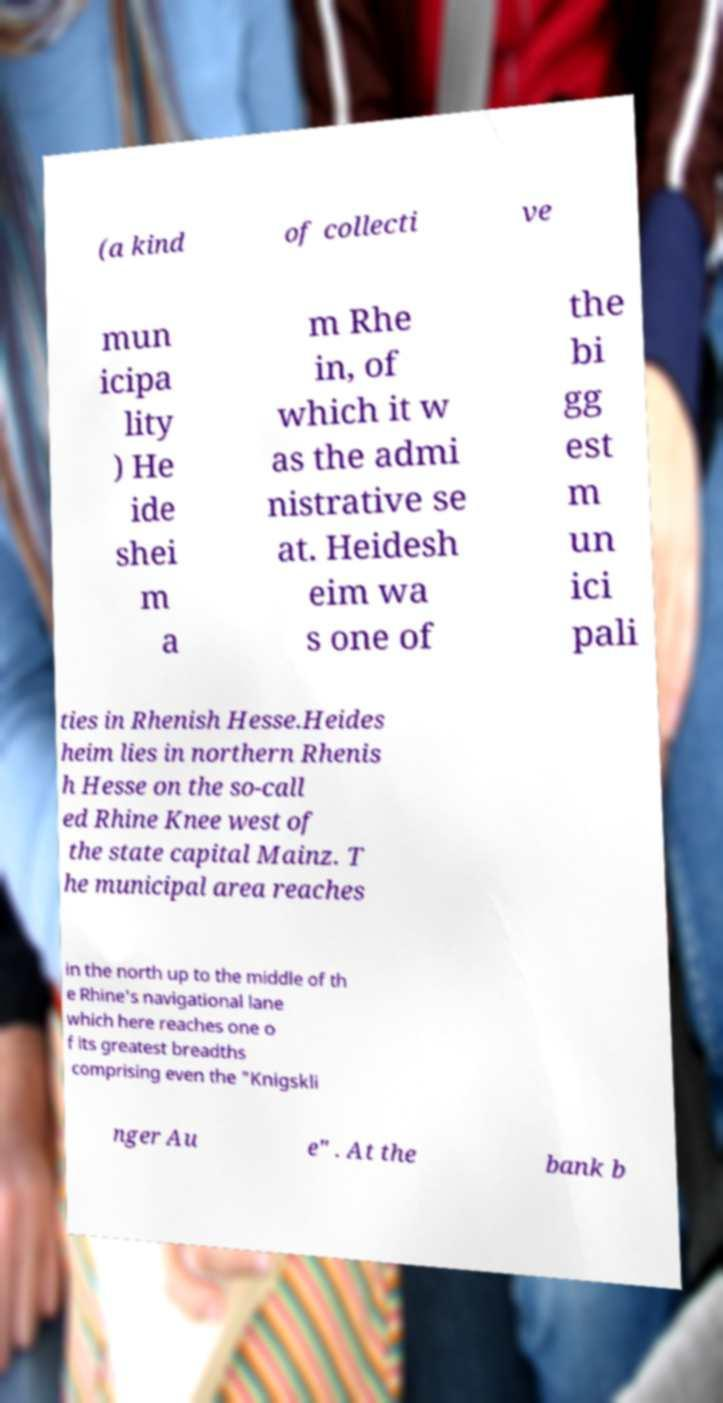There's text embedded in this image that I need extracted. Can you transcribe it verbatim? (a kind of collecti ve mun icipa lity ) He ide shei m a m Rhe in, of which it w as the admi nistrative se at. Heidesh eim wa s one of the bi gg est m un ici pali ties in Rhenish Hesse.Heides heim lies in northern Rhenis h Hesse on the so-call ed Rhine Knee west of the state capital Mainz. T he municipal area reaches in the north up to the middle of th e Rhine's navigational lane which here reaches one o f its greatest breadths comprising even the "Knigskli nger Au e" . At the bank b 